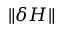Convert formula to latex. <formula><loc_0><loc_0><loc_500><loc_500>\| \delta H \|</formula> 